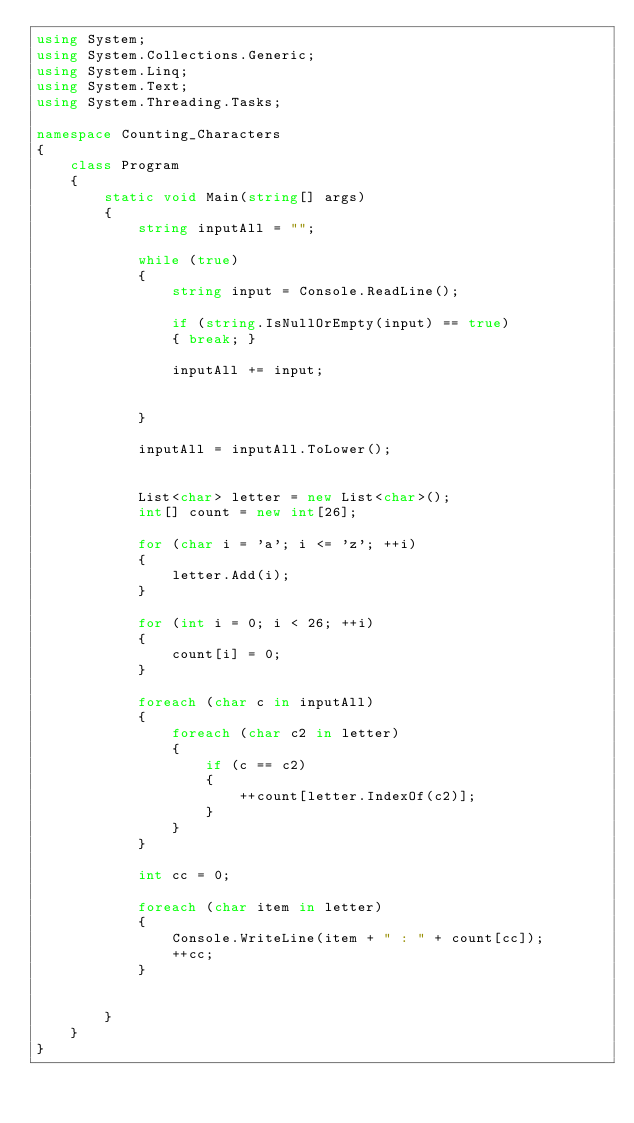Convert code to text. <code><loc_0><loc_0><loc_500><loc_500><_C#_>using System;
using System.Collections.Generic;
using System.Linq;
using System.Text;
using System.Threading.Tasks;

namespace Counting_Characters
{
    class Program
    {
        static void Main(string[] args)
        {
            string inputAll = "";

            while (true)
            {
                string input = Console.ReadLine();
                
                if (string.IsNullOrEmpty(input) == true)
                { break; }

                inputAll += input;

                
            }

            inputAll = inputAll.ToLower();


            List<char> letter = new List<char>();
            int[] count = new int[26];

            for (char i = 'a'; i <= 'z'; ++i)
            {
                letter.Add(i);
            }

            for (int i = 0; i < 26; ++i)
            {
                count[i] = 0;
            }

            foreach (char c in inputAll)
            {
                foreach (char c2 in letter)
                {
                    if (c == c2)
                    {
                        ++count[letter.IndexOf(c2)];
                    }
                }
            }

            int cc = 0;

            foreach (char item in letter)
            {                
                Console.WriteLine(item + " : " + count[cc]);
                ++cc;
            }

            
        }
    }
}

</code> 